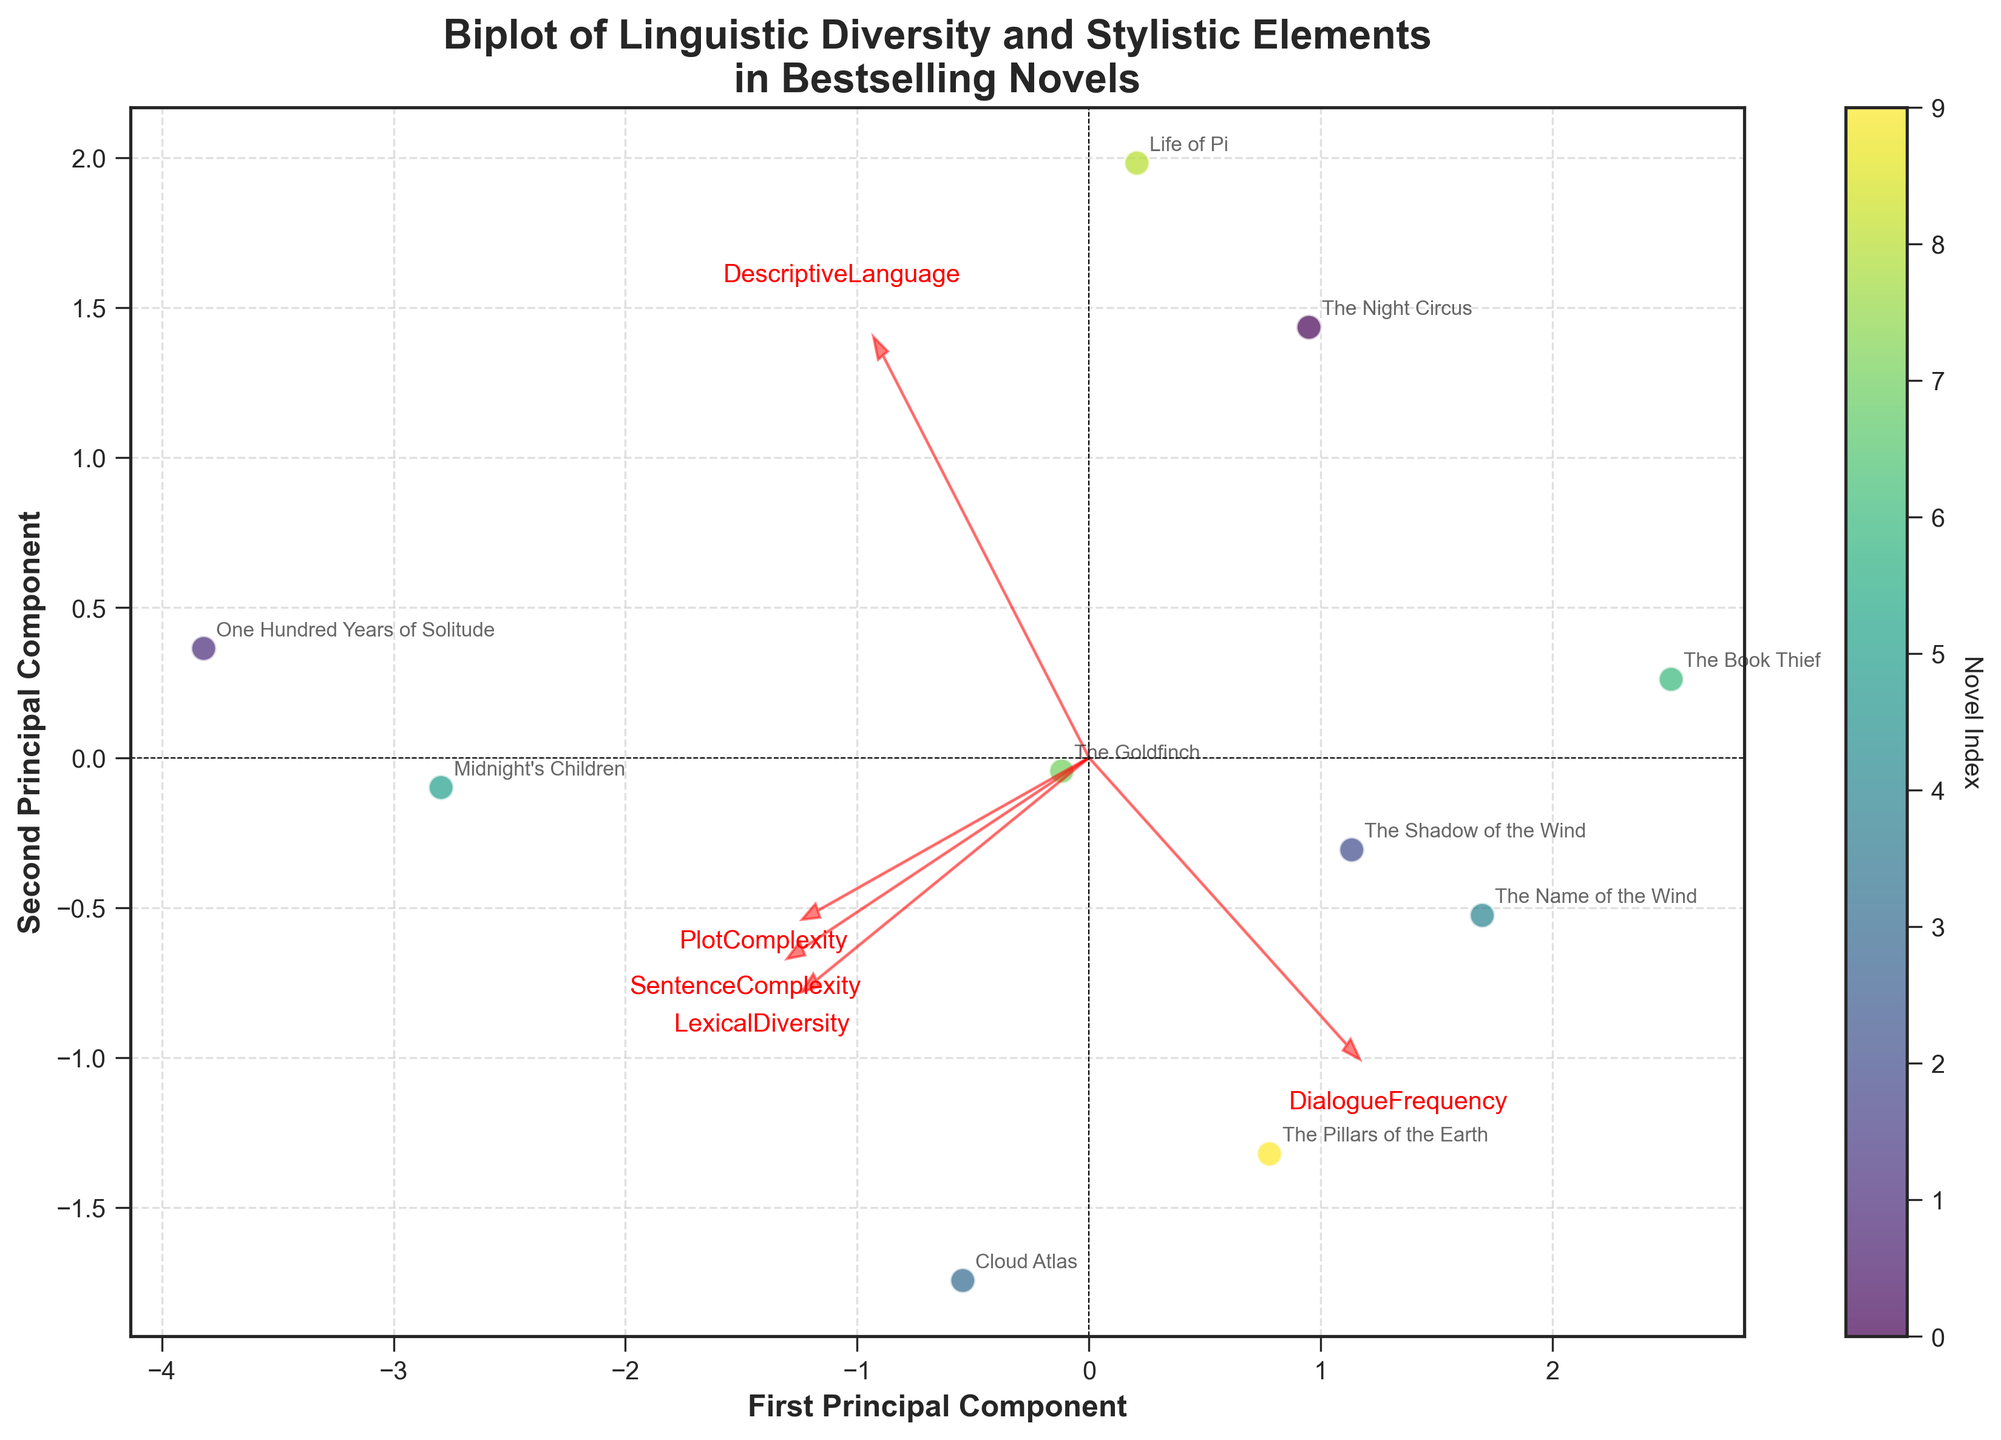What is the title of the plot? The title of the plot is positioned at the top center of the figure. By looking at the diagram, it is clear that it reads "Biplot of Linguistic Diversity and Stylistic Elements\nin Bestselling Novels".
Answer: Biplot of Linguistic Diversity and Stylistic Elements\nin Bestselling Novels How many novels are represented in the figure? To determine the number of novels, count the number of distinct scatter points or annotations present in the biplot. Each scatter point or annotation represents a novel.
Answer: 10 Which two novels appear closest to each other in the biplot? To answer this, visually inspect the distances between the scatter points. The two points that are closest together represent the novels that are nearest in terms of the principal components.
Answer: "The Night Circus" and "The Book Thief" Does "Midnight's Children" have higher first principal component scores than "Life of Pi"? Locate the positions of "Midnight's Children" and "Life of Pi" on the biplot and compare their x-axis (first principal component) values. The novel that is further to the right on the x-axis has a higher score.
Answer: Yes Which feature vector has the largest arrow length? To determine this, compare the lengths of the arrows (representing feature vectors) originating from the origin (0,0). The longest arrow indicates the feature with the largest contribution to the principal components.
Answer: DescriptiveLanguage What is the position of "The Goldfinch" in terms of the second principal component? Locate "The Goldfinch" on the biplot and note its y-axis (second principal component) position. This will indicate its value for the second component.
Answer: Positive How does the PlotComplexity vector compare to the DialogueFrequency vector in the biplot? Observe the directions and lengths of the PlotComplexity and DialogueFrequency vectors. Comparison involves checking their angles with the principal components and their lengths.
Answer: Longer and in a similar direction as LexicalDiversity Which novel has the highest second principal component score? Identify the highest scatter point along the y-axis (second principal component) to determine which novel has the highest score on this axis.
Answer: "Midnight's Children" Are the directions of SentenceComplexity and PlotComplexity vectors aligned? By looking at the angles of the arrows representing these two features, we can determine if they point in similar directions, indicating a potential correlation.
Answer: Partially aligned Is "One Hundred Years of Solitude" positioned in the positive or negative side of the first principal component? Locate "One Hundred Years of Solitude" on the biplot and check its position relative to the origin on the x-axis (first principal component).
Answer: Positive 